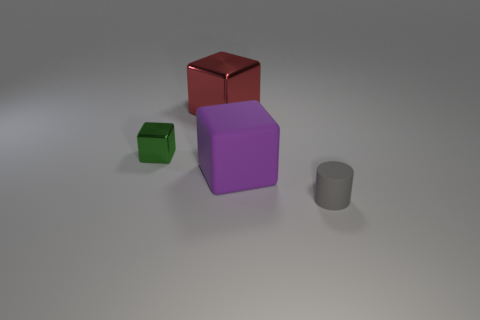Subtract all shiny blocks. How many blocks are left? 1 Add 1 small cyan objects. How many objects exist? 5 Subtract all cylinders. How many objects are left? 3 Subtract all small metallic cubes. Subtract all green cubes. How many objects are left? 2 Add 2 large purple blocks. How many large purple blocks are left? 3 Add 4 large yellow matte blocks. How many large yellow matte blocks exist? 4 Subtract 0 blue cylinders. How many objects are left? 4 